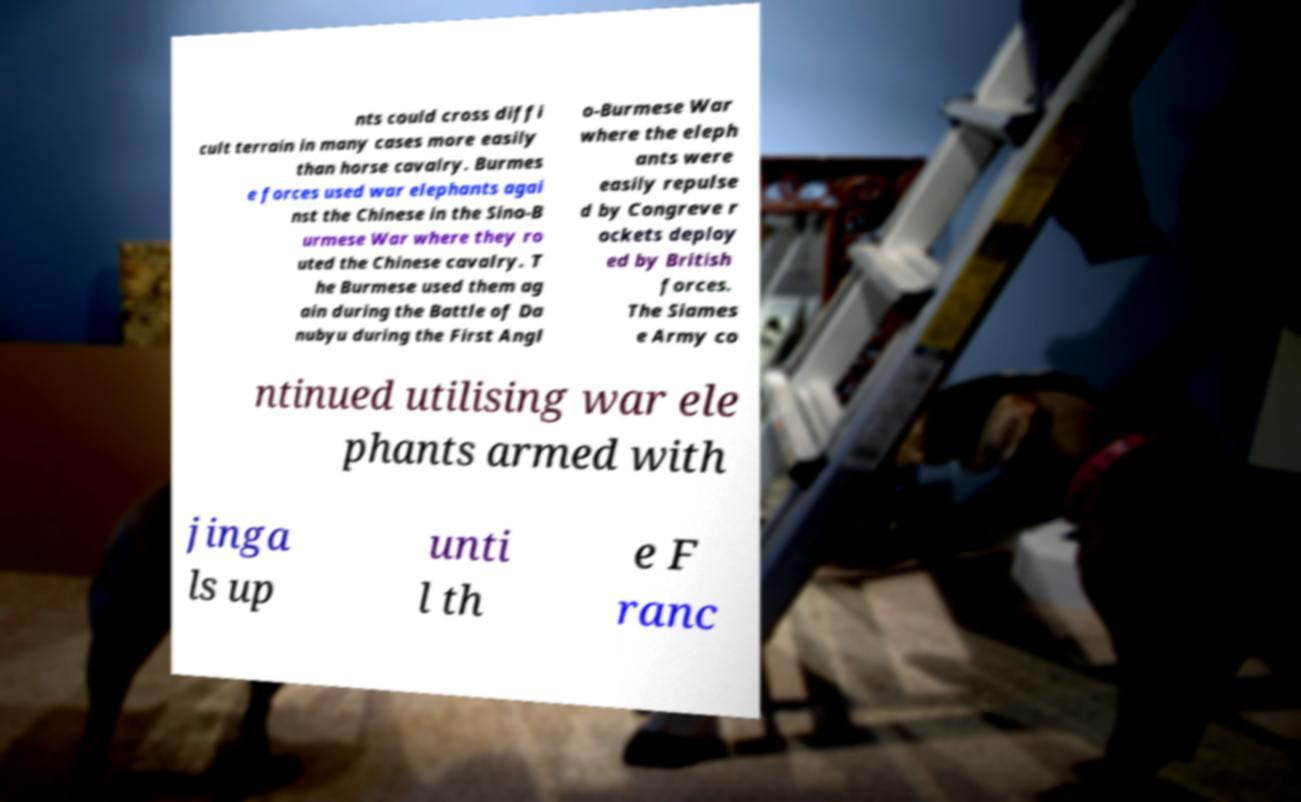What messages or text are displayed in this image? I need them in a readable, typed format. nts could cross diffi cult terrain in many cases more easily than horse cavalry. Burmes e forces used war elephants agai nst the Chinese in the Sino-B urmese War where they ro uted the Chinese cavalry. T he Burmese used them ag ain during the Battle of Da nubyu during the First Angl o-Burmese War where the eleph ants were easily repulse d by Congreve r ockets deploy ed by British forces. The Siames e Army co ntinued utilising war ele phants armed with jinga ls up unti l th e F ranc 